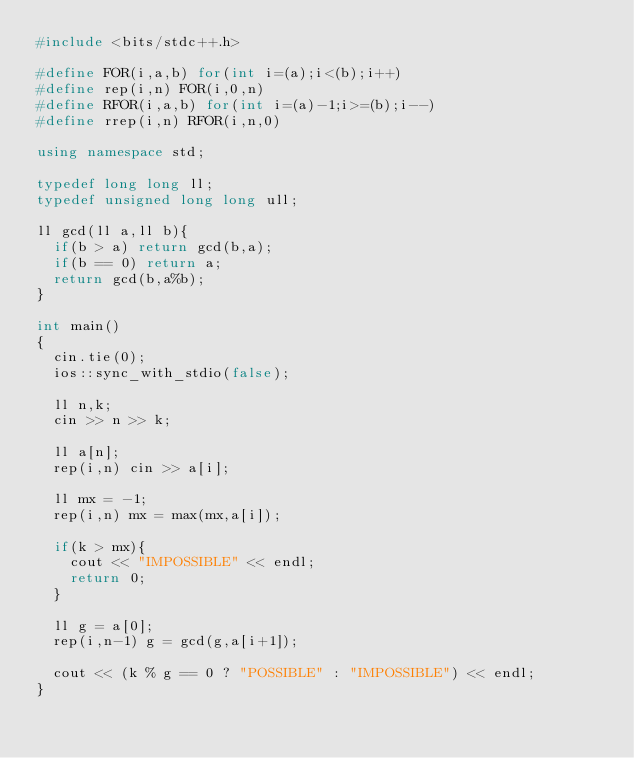<code> <loc_0><loc_0><loc_500><loc_500><_C++_>#include <bits/stdc++.h>

#define FOR(i,a,b) for(int i=(a);i<(b);i++)
#define rep(i,n) FOR(i,0,n)
#define RFOR(i,a,b) for(int i=(a)-1;i>=(b);i--)
#define rrep(i,n) RFOR(i,n,0)

using namespace std;

typedef long long ll;
typedef unsigned long long ull;

ll gcd(ll a,ll b){
	if(b > a) return gcd(b,a);
	if(b == 0) return a;
	return gcd(b,a%b);
}

int main()
{
	cin.tie(0);
	ios::sync_with_stdio(false);

	ll n,k;
	cin >> n >> k;

	ll a[n];
	rep(i,n) cin >> a[i];

	ll mx = -1;
	rep(i,n) mx = max(mx,a[i]);

	if(k > mx){
		cout << "IMPOSSIBLE" << endl;
		return 0;
	} 

	ll g = a[0];
	rep(i,n-1) g = gcd(g,a[i+1]);

	cout << (k % g == 0 ? "POSSIBLE" : "IMPOSSIBLE") << endl;	
}</code> 